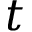Convert formula to latex. <formula><loc_0><loc_0><loc_500><loc_500>t</formula> 